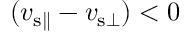<formula> <loc_0><loc_0><loc_500><loc_500>( v _ { { s } \| } - v _ { { s } \bot } ) < 0</formula> 